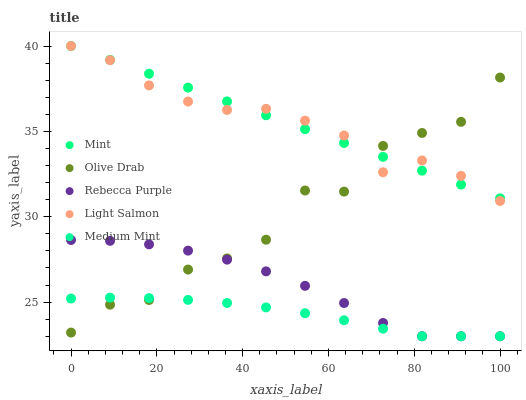Does Medium Mint have the minimum area under the curve?
Answer yes or no. Yes. Does Mint have the maximum area under the curve?
Answer yes or no. Yes. Does Light Salmon have the minimum area under the curve?
Answer yes or no. No. Does Light Salmon have the maximum area under the curve?
Answer yes or no. No. Is Mint the smoothest?
Answer yes or no. Yes. Is Olive Drab the roughest?
Answer yes or no. Yes. Is Light Salmon the smoothest?
Answer yes or no. No. Is Light Salmon the roughest?
Answer yes or no. No. Does Medium Mint have the lowest value?
Answer yes or no. Yes. Does Light Salmon have the lowest value?
Answer yes or no. No. Does Mint have the highest value?
Answer yes or no. Yes. Does Rebecca Purple have the highest value?
Answer yes or no. No. Is Medium Mint less than Mint?
Answer yes or no. Yes. Is Mint greater than Medium Mint?
Answer yes or no. Yes. Does Rebecca Purple intersect Medium Mint?
Answer yes or no. Yes. Is Rebecca Purple less than Medium Mint?
Answer yes or no. No. Is Rebecca Purple greater than Medium Mint?
Answer yes or no. No. Does Medium Mint intersect Mint?
Answer yes or no. No. 